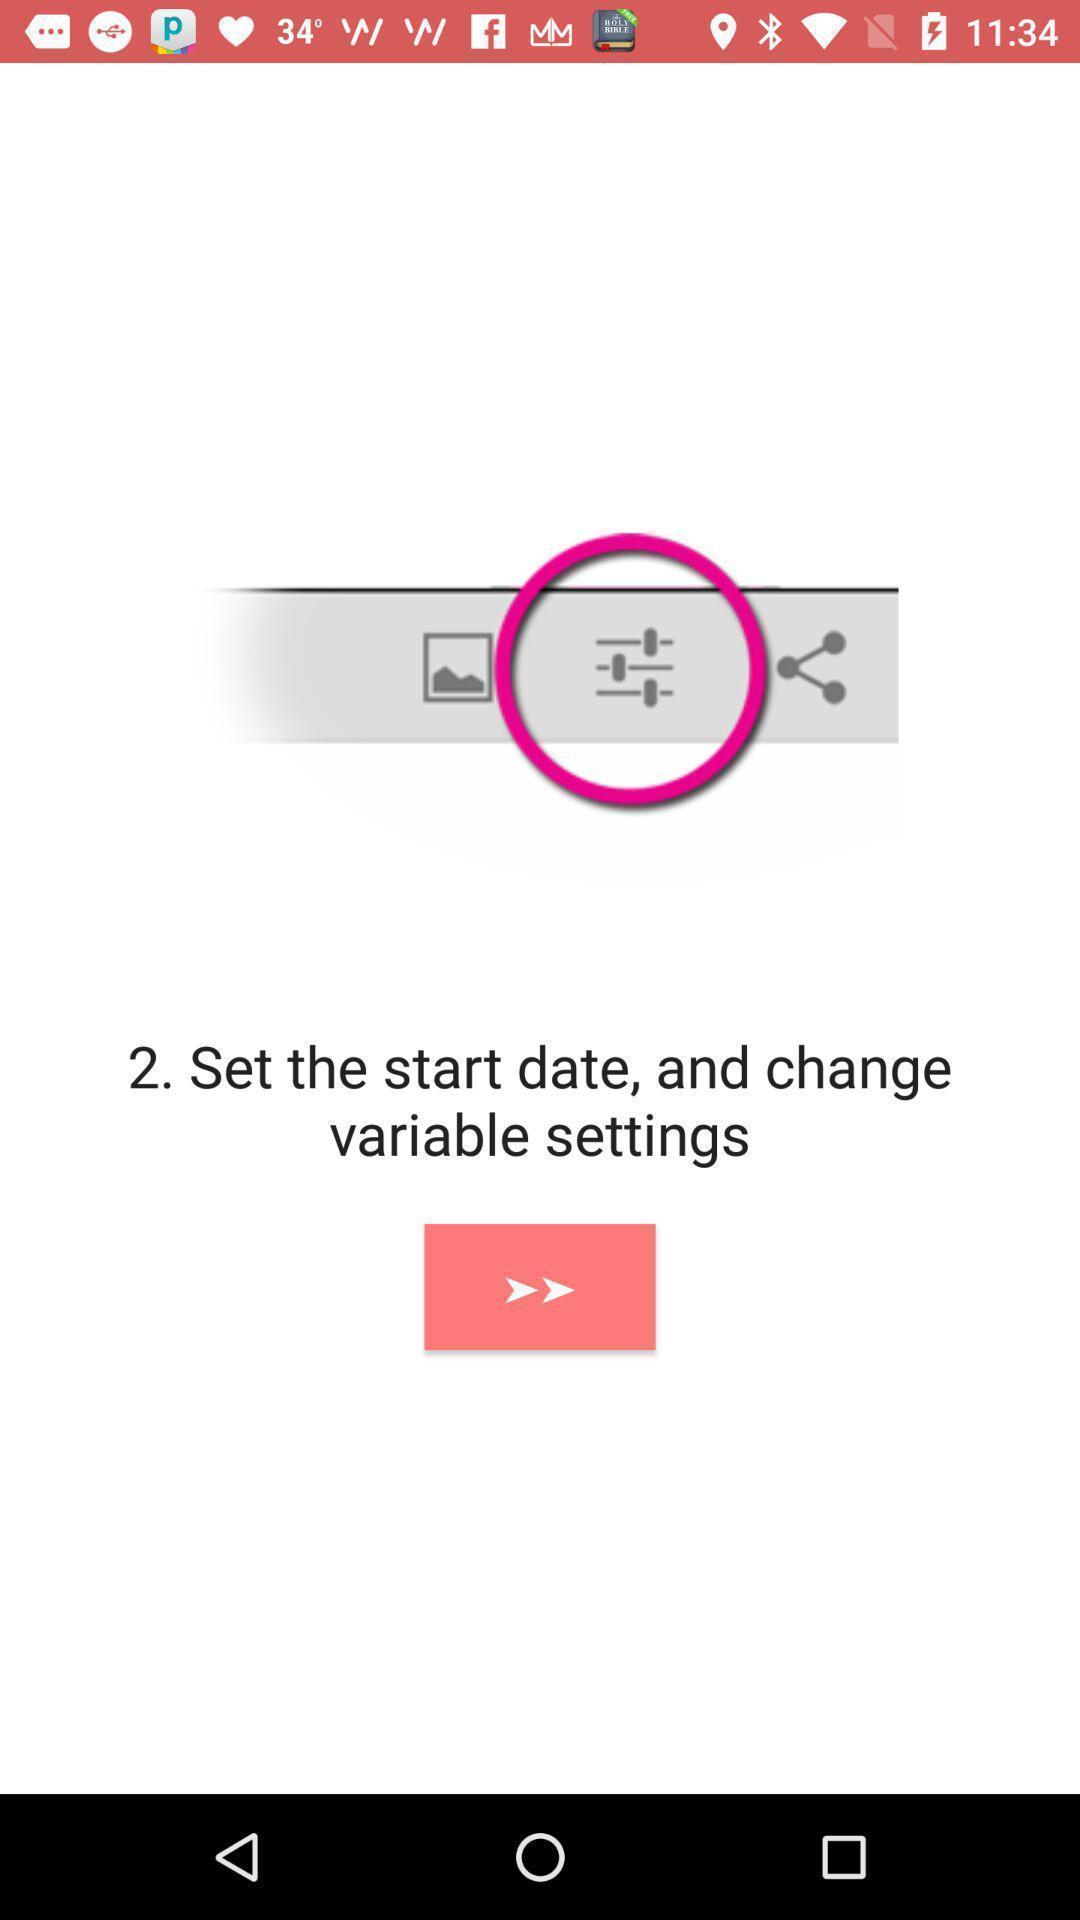Explain the elements present in this screenshot. Settings page in a social app. 